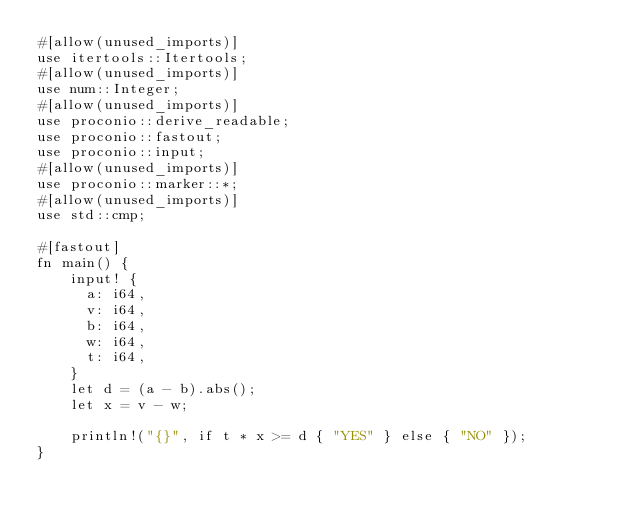Convert code to text. <code><loc_0><loc_0><loc_500><loc_500><_Rust_>#[allow(unused_imports)]
use itertools::Itertools;
#[allow(unused_imports)]
use num::Integer;
#[allow(unused_imports)]
use proconio::derive_readable;
use proconio::fastout;
use proconio::input;
#[allow(unused_imports)]
use proconio::marker::*;
#[allow(unused_imports)]
use std::cmp;

#[fastout]
fn main() {
    input! {
      a: i64,
      v: i64,
      b: i64,
      w: i64,
      t: i64,
    }
    let d = (a - b).abs();
    let x = v - w;

    println!("{}", if t * x >= d { "YES" } else { "NO" });
}
</code> 